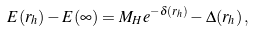Convert formula to latex. <formula><loc_0><loc_0><loc_500><loc_500>E ( r _ { h } ) - E ( \infty ) = M _ { H } e ^ { - \delta ( r _ { h } ) } - \Delta ( r _ { h } ) \, ,</formula> 